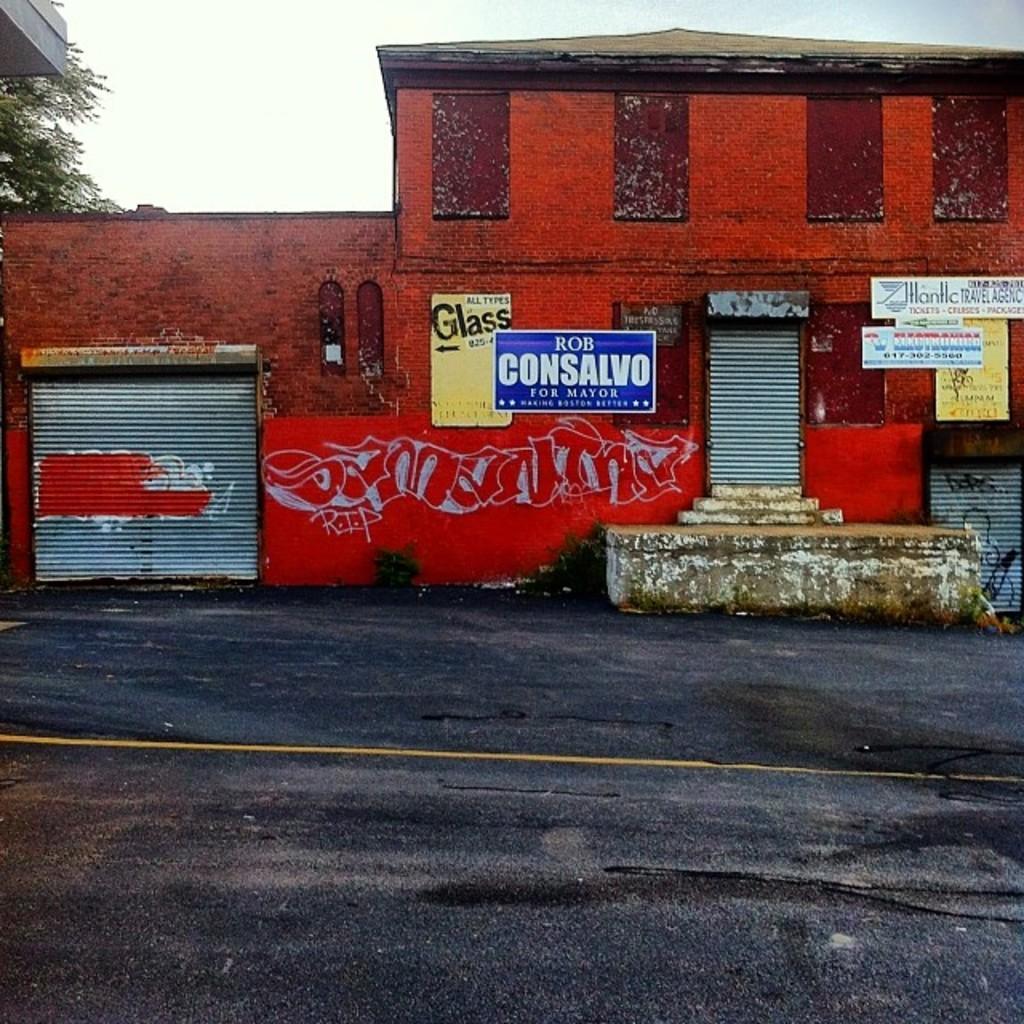Describe this image in one or two sentences. As we can see in the image there are buildings, posters, rolling shutter and tree. On the top there is sky. 